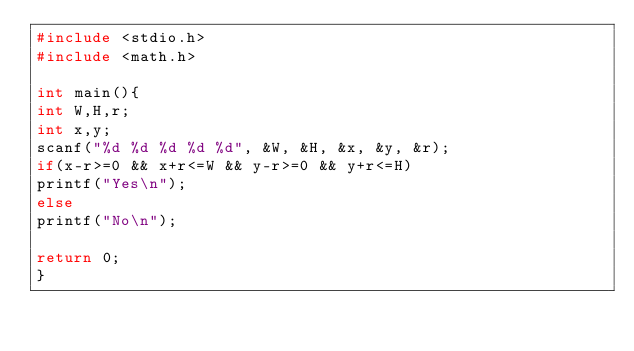Convert code to text. <code><loc_0><loc_0><loc_500><loc_500><_C_>#include <stdio.h>
#include <math.h>

int main(){
int	W,H,r;
int	x,y;
scanf("%d %d %d %d %d", &W, &H, &x, &y, &r);
if(x-r>=0 && x+r<=W && y-r>=0 && y+r<=H)
printf("Yes\n");
else
printf("No\n");

return 0;
}</code> 